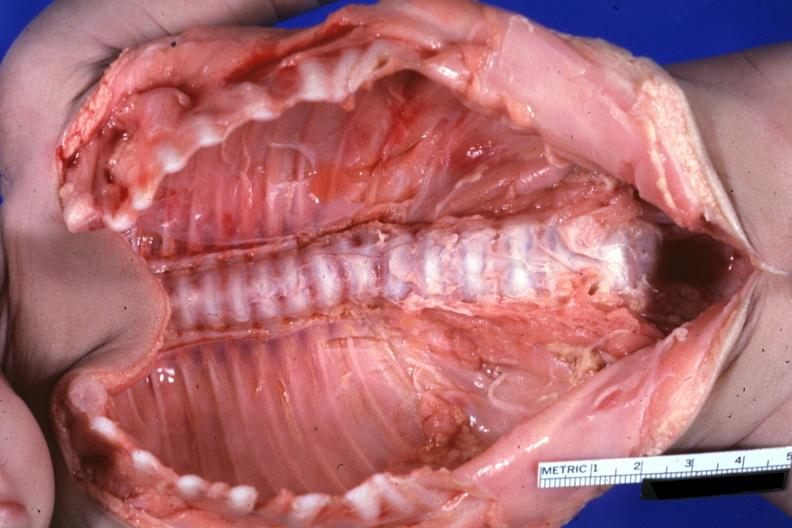what see protocol?
Answer the question using a single word or phrase. Natural color lesion at t12 